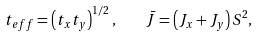<formula> <loc_0><loc_0><loc_500><loc_500>t _ { e f f } = \left ( t _ { x } t _ { y } \right ) ^ { 1 / 2 } , \quad \bar { J } = \left ( J _ { x } + J _ { y } \right ) S ^ { 2 } ,</formula> 